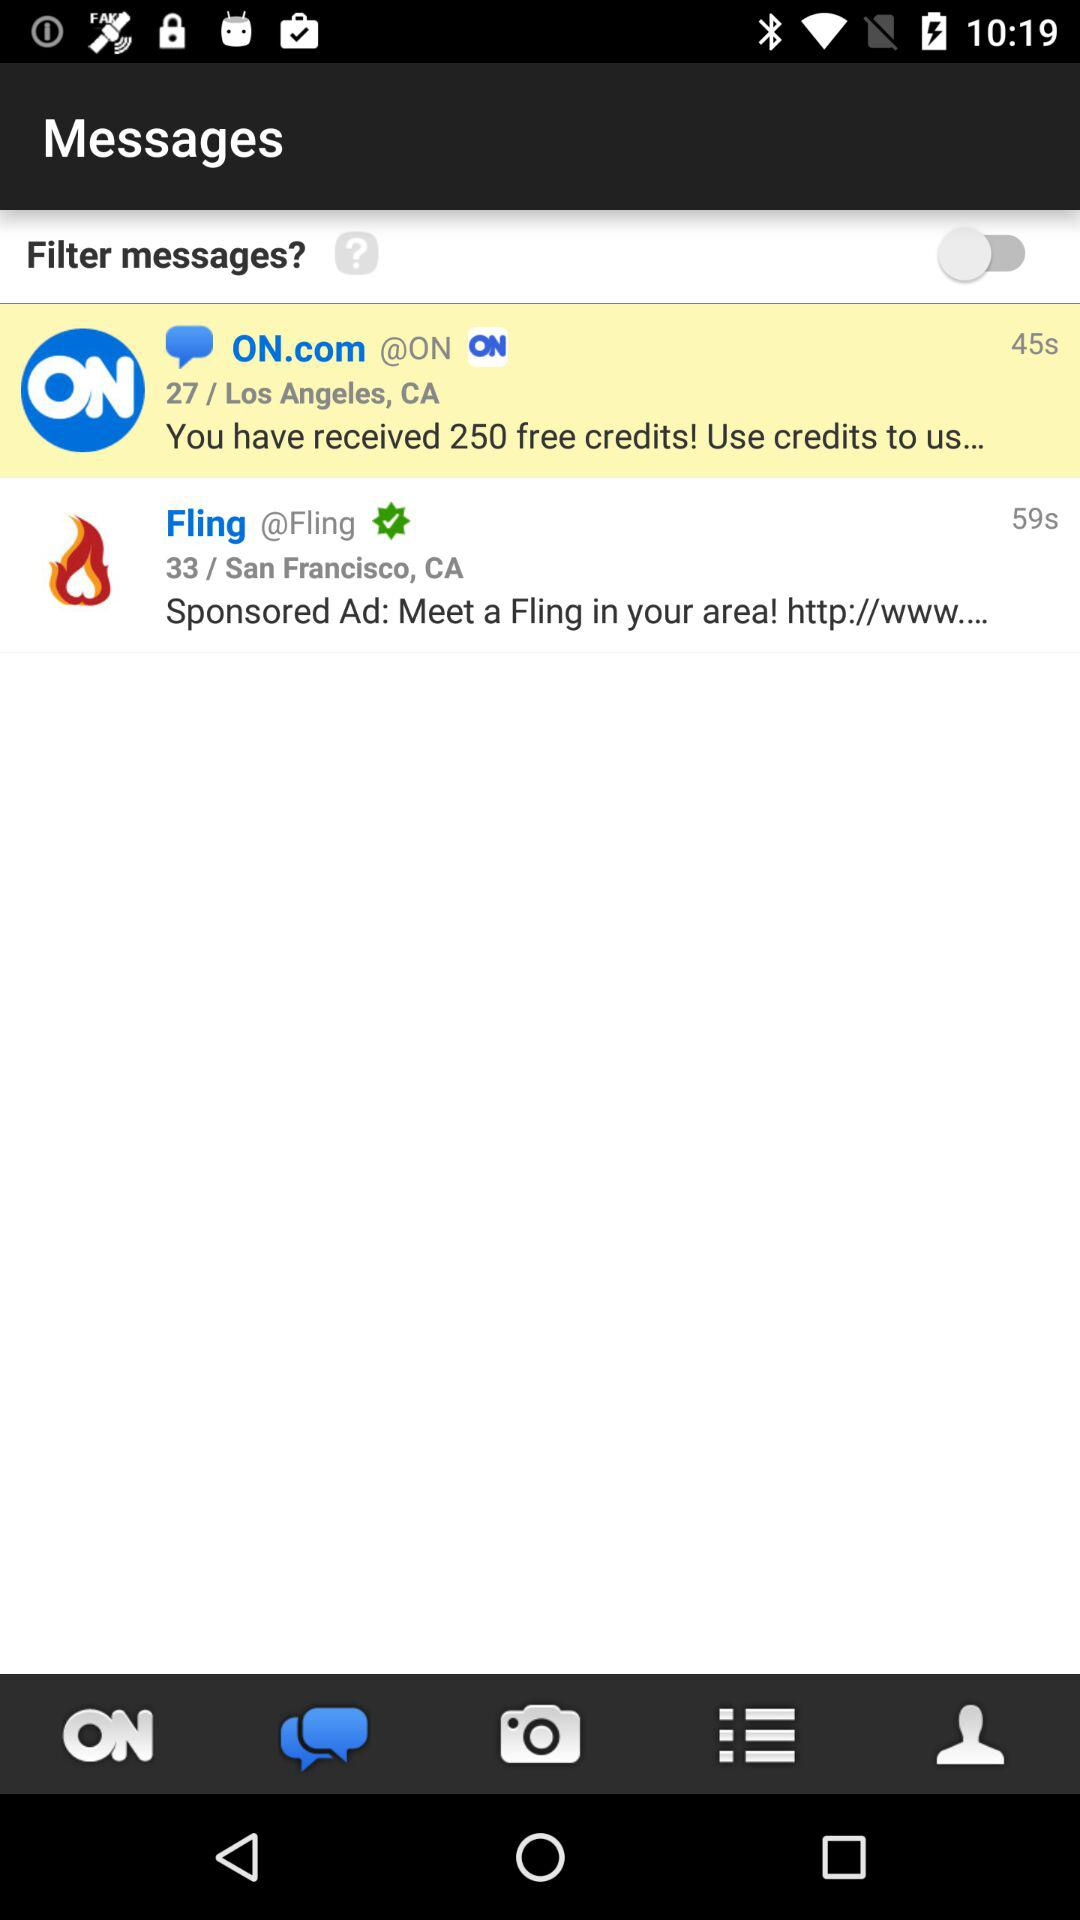What is the location given in the first message? The given location in the first message is 27 / Los Angeles, CA. 